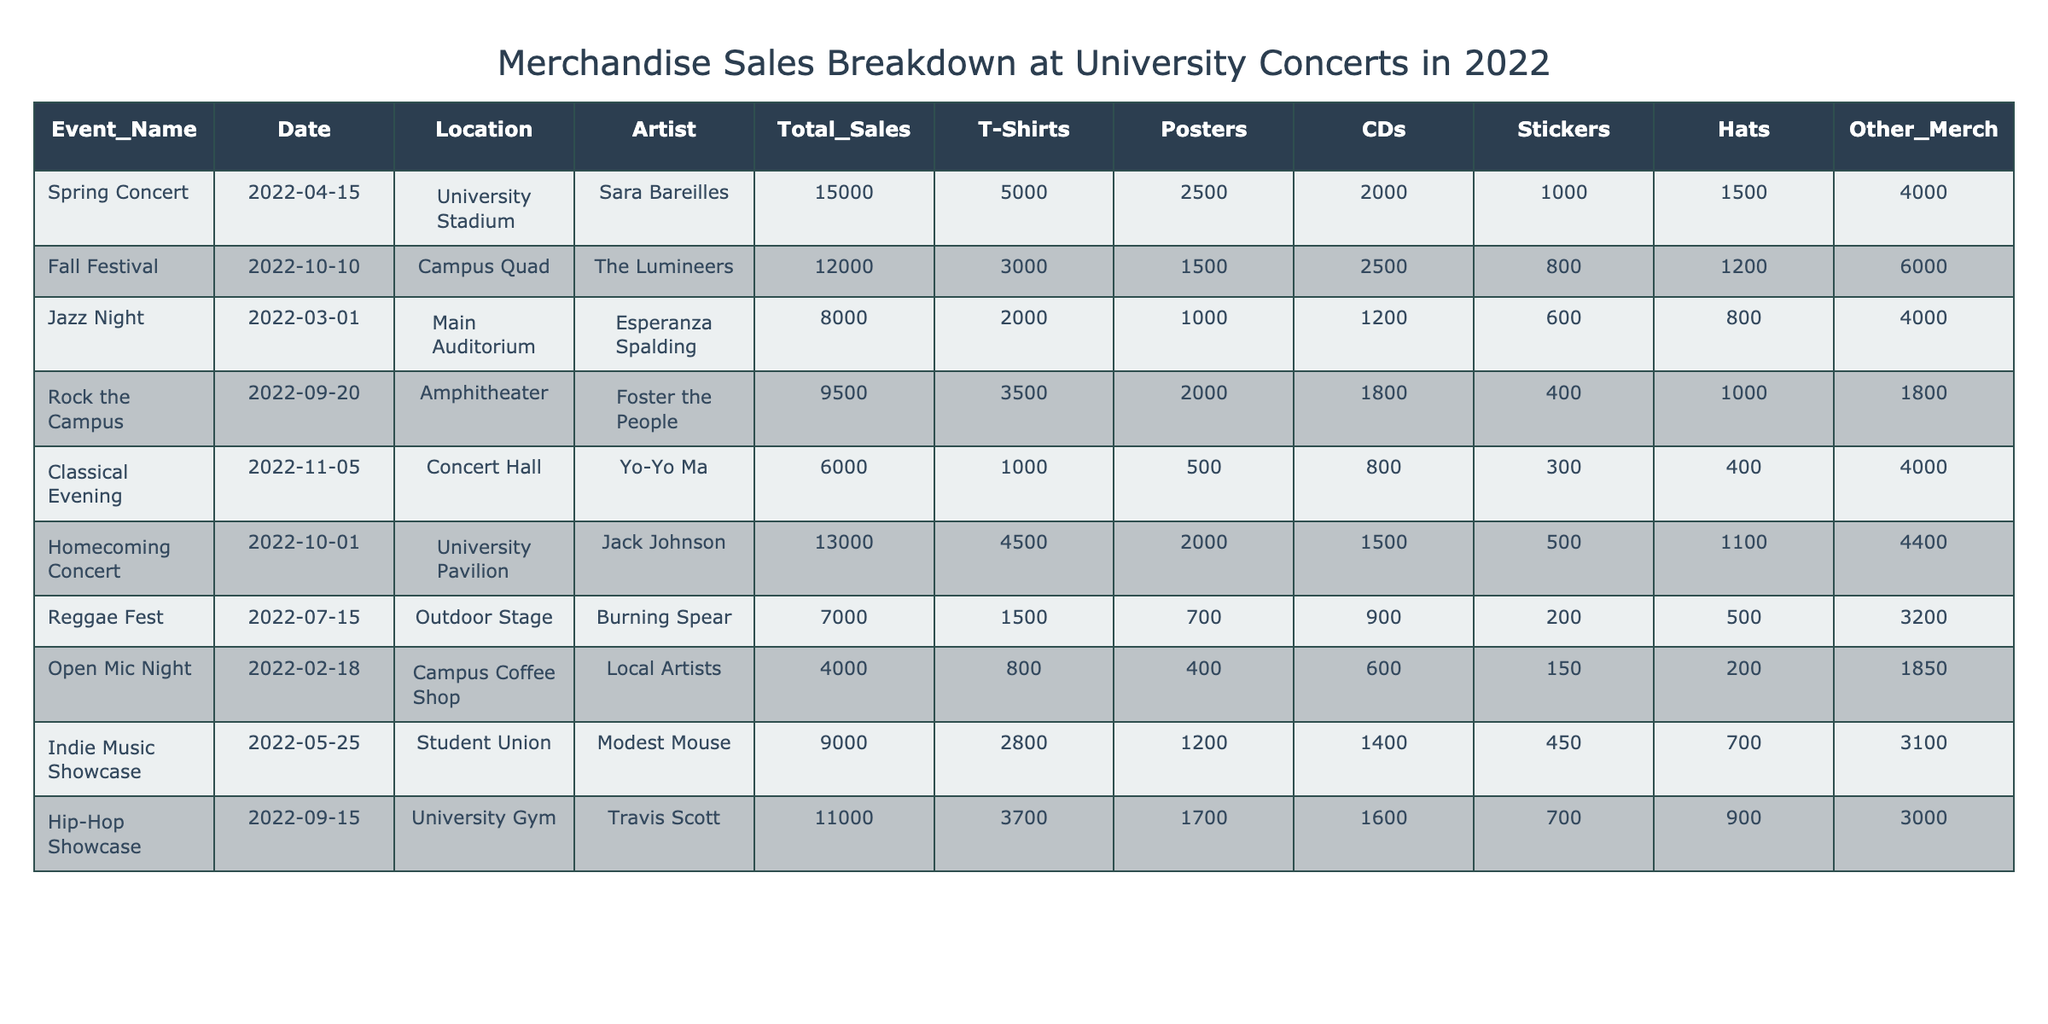What was the total sales for the Homecoming Concert? The total sales for the Homecoming Concert as listed in the table is 13000. Simply find the value in the "Total_Sales" column for the event named "Homecoming Concert".
Answer: 13000 Which event had the highest merchandise sales? By comparing the values in the "Total_Sales" column, the Spring Concert had the highest sales at 15000.
Answer: Spring Concert What is the average sales of T-Shirts across all events? The total number of T-Shirts sold is (5000 + 3000 + 2000 + 3500 + 1000 + 4500 + 1500 + 800 + 2800 + 3700) = 22800. There are 10 events, so the average is 22800 / 10 = 2280.
Answer: 2280 Did the Jazz Night have more sticker sales than the Classical Evening? The Jazz Night had 800 sticker sales, while the Classical Evening had 300 sticker sales. Since 800 is greater than 300, the statement is true.
Answer: Yes Which two events had more than $10,000 in total sales? The events with total sales over $10,000 are the Spring Concert (15000) and the Homecoming Concert (13000), as seen in the "Total_Sales" column.
Answer: Spring Concert and Homecoming Concert What was the total sales for all events combined? To find the total sales across all events, sum the values in the "Total_Sales" column: 15000 + 12000 + 8000 + 9500 + 6000 + 13000 + 7000 + 4000 + 9000 + 11000 =  80000.
Answer: 80000 Which artist had the lowest total merchandise sales? Comparing total sales, the Classical Evening featuring Yo-Yo Ma had the lowest at 6000.
Answer: Yo-Yo Ma Calculate the percentage of total sales that came from stickers across all events. Total sticker sales are 1000 + 800 + 600 + 400 + 300 + 500 + 200 + 150 + 450 + 700 = 5100. The total sales are 80000, so percentage = (5100 / 80000) * 100 = 6.375%.
Answer: 6.375% Which location had the highest average sales per event, given the total sales for the events held there? Calculate average sales per event by dividing total sales by the number of events at each location. For University Stadium: 15000 / 1 = 15000, Campus Quad: 12000 / 1 = 12000, Main Auditorium: 8000 / 1 = 8000, Amphitheater: 9500 / 1 = 9500, Concert Hall: 6000 / 1 = 6000, University Pavilion: 13000 / 1 = 13000, Outdoor Stage: 7000 / 1 = 7000, Campus Coffee Shop: 4000 / 1 = 4000, Student Union: 9000 / 1 = 9000, University Gym: 11000 / 1 = 11000. The highest average sales per event is 15000 at University Stadium.
Answer: University Stadium 